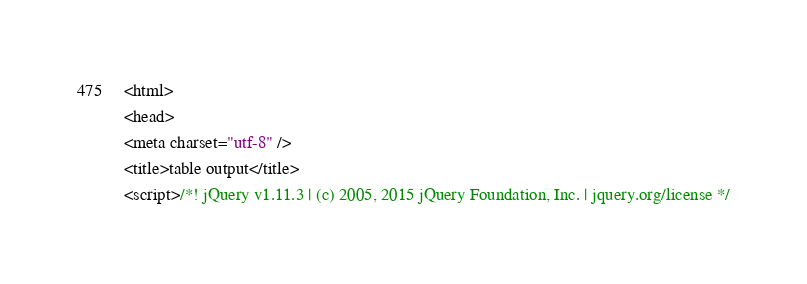<code> <loc_0><loc_0><loc_500><loc_500><_HTML_><html>
<head>
<meta charset="utf-8" />
<title>table output</title>
<script>/*! jQuery v1.11.3 | (c) 2005, 2015 jQuery Foundation, Inc. | jquery.org/license */</code> 